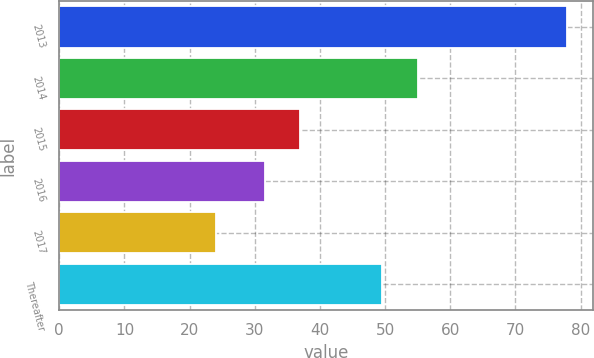Convert chart. <chart><loc_0><loc_0><loc_500><loc_500><bar_chart><fcel>2013<fcel>2014<fcel>2015<fcel>2016<fcel>2017<fcel>Thereafter<nl><fcel>78<fcel>54.99<fcel>36.99<fcel>31.6<fcel>24.1<fcel>49.6<nl></chart> 